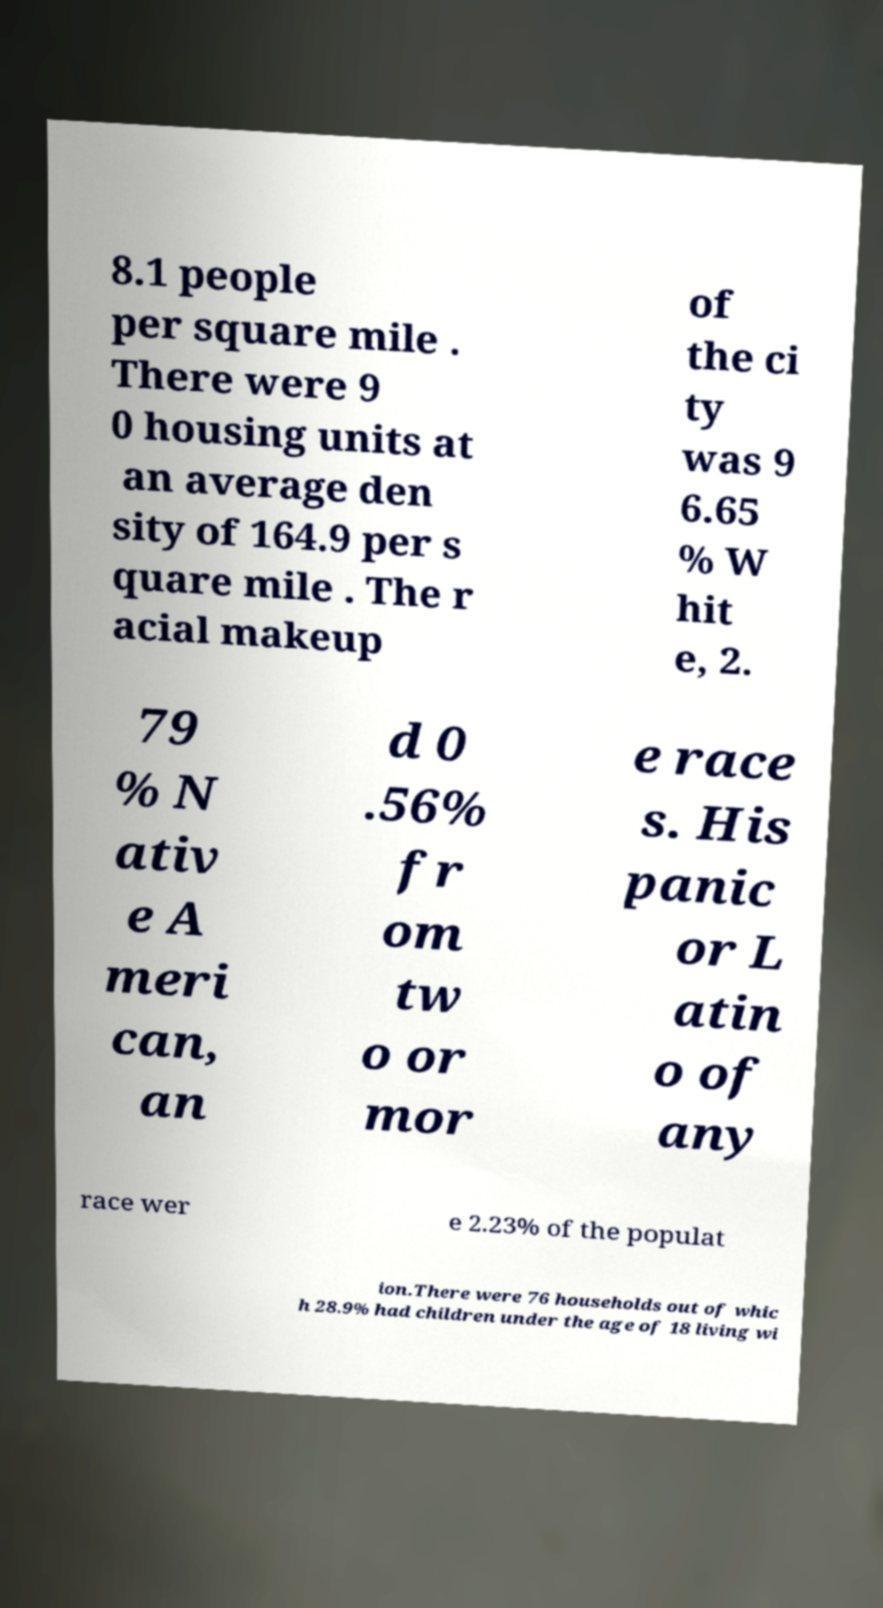Please read and relay the text visible in this image. What does it say? 8.1 people per square mile . There were 9 0 housing units at an average den sity of 164.9 per s quare mile . The r acial makeup of the ci ty was 9 6.65 % W hit e, 2. 79 % N ativ e A meri can, an d 0 .56% fr om tw o or mor e race s. His panic or L atin o of any race wer e 2.23% of the populat ion.There were 76 households out of whic h 28.9% had children under the age of 18 living wi 